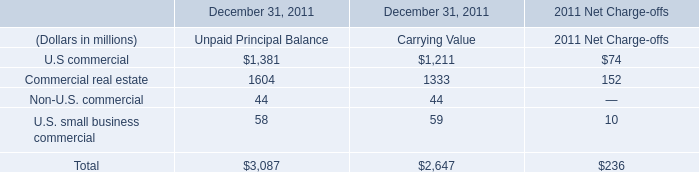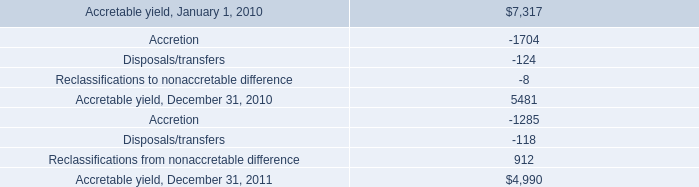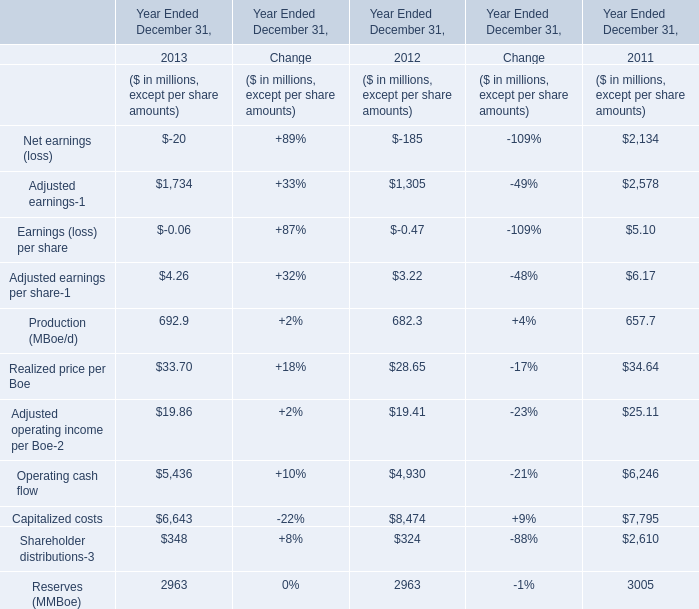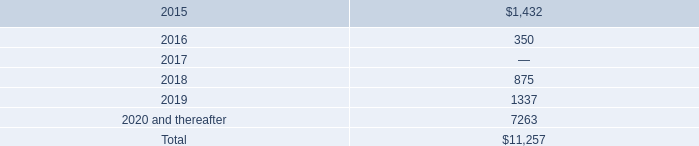what percentage increase occurred from oct 24 , 2017 to oct 24 , 2018 of senior credit facility maturity? 
Computations: (((164 - 30) / 30) * 100)
Answer: 446.66667. 